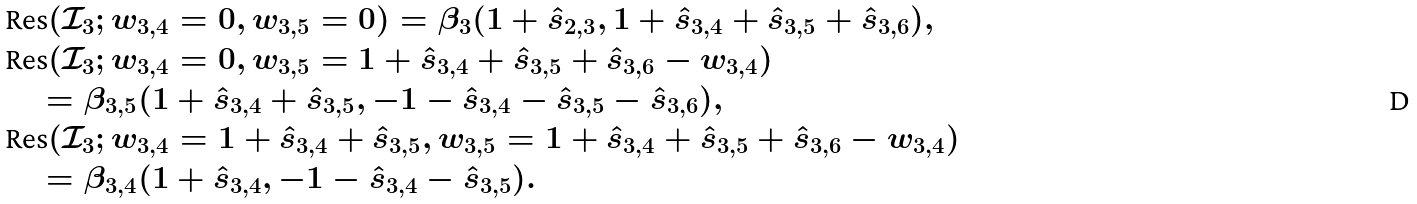Convert formula to latex. <formula><loc_0><loc_0><loc_500><loc_500>& \text {Res} ( \mathcal { I } _ { 3 } ; w _ { 3 , 4 } = 0 , w _ { 3 , 5 } = 0 ) = \beta _ { 3 } ( 1 + \hat { s } _ { 2 , 3 } , 1 + \hat { s } _ { 3 , 4 } + \hat { s } _ { 3 , 5 } + \hat { s } _ { 3 , 6 } ) , \\ & \text {Res} ( \mathcal { I } _ { 3 } ; w _ { 3 , 4 } = 0 , w _ { 3 , 5 } = 1 + \hat { s } _ { 3 , 4 } + \hat { s } _ { 3 , 5 } + \hat { s } _ { 3 , 6 } - w _ { 3 , 4 } ) \\ & \quad = \beta _ { 3 , 5 } ( 1 + \hat { s } _ { 3 , 4 } + \hat { s } _ { 3 , 5 } , - 1 - \hat { s } _ { 3 , 4 } - \hat { s } _ { 3 , 5 } - \hat { s } _ { 3 , 6 } ) , \\ & \text {Res} ( \mathcal { I } _ { 3 } ; w _ { 3 , 4 } = 1 + \hat { s } _ { 3 , 4 } + \hat { s } _ { 3 , 5 } , w _ { 3 , 5 } = 1 + \hat { s } _ { 3 , 4 } + \hat { s } _ { 3 , 5 } + \hat { s } _ { 3 , 6 } - w _ { 3 , 4 } ) \\ & \quad = \beta _ { 3 , 4 } ( 1 + \hat { s } _ { 3 , 4 } , - 1 - \hat { s } _ { 3 , 4 } - \hat { s } _ { 3 , 5 } ) .</formula> 